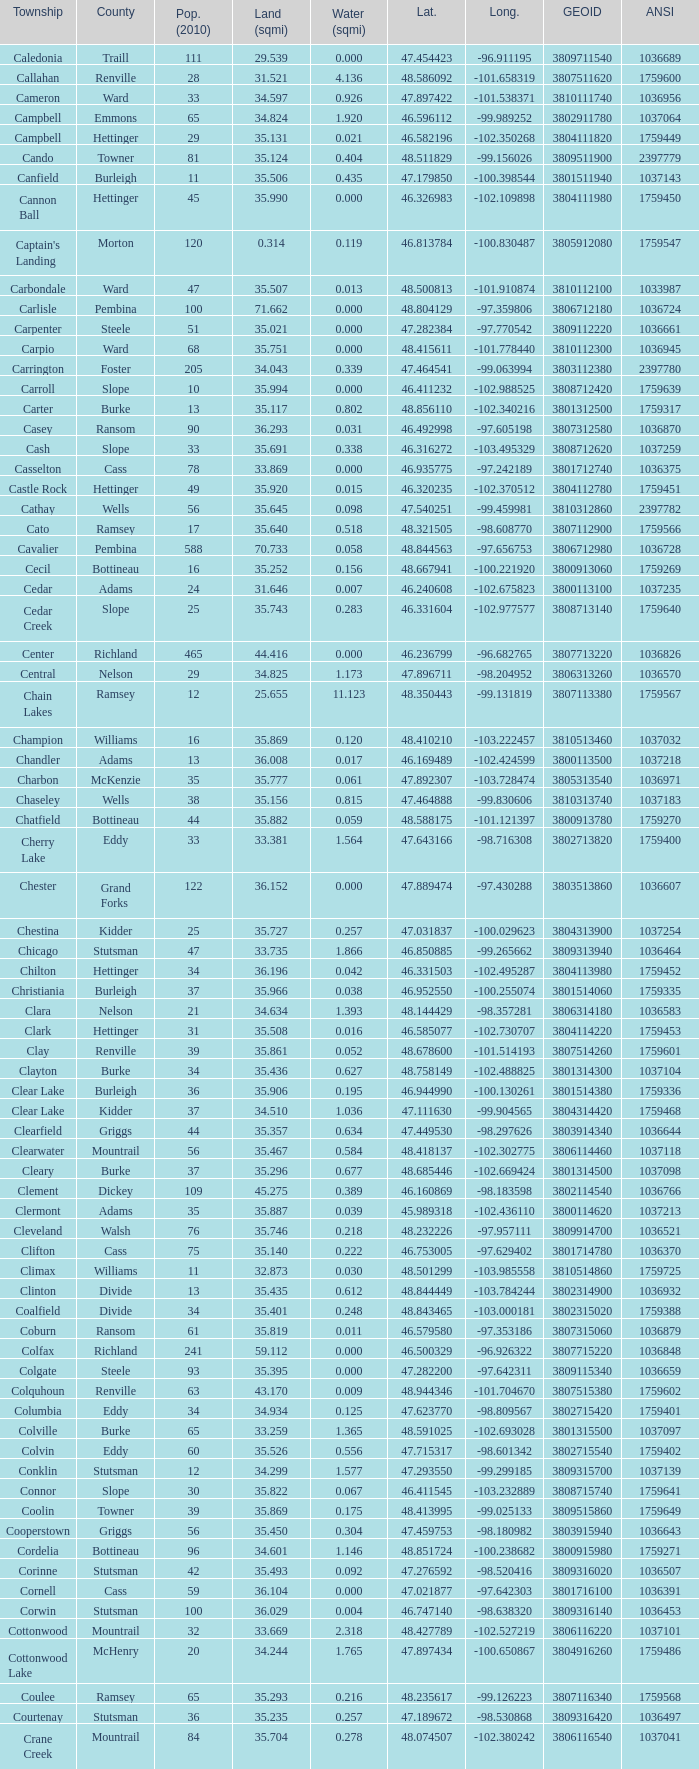What was the county with a longitude of -102.302775? Mountrail. 